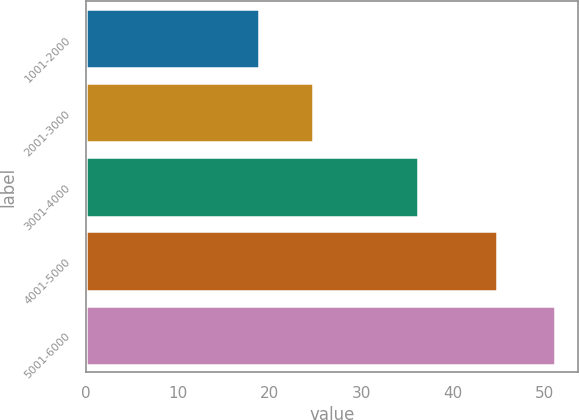Convert chart to OTSL. <chart><loc_0><loc_0><loc_500><loc_500><bar_chart><fcel>1001-2000<fcel>2001-3000<fcel>3001-4000<fcel>4001-5000<fcel>5001-6000<nl><fcel>18.86<fcel>24.77<fcel>36.22<fcel>44.8<fcel>51.08<nl></chart> 